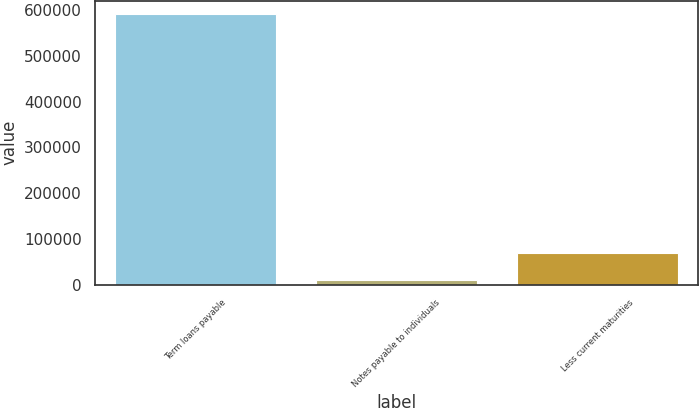<chart> <loc_0><loc_0><loc_500><loc_500><bar_chart><fcel>Term loans payable<fcel>Notes payable to individuals<fcel>Less current maturities<nl><fcel>590099<fcel>10855<fcel>68779.4<nl></chart> 